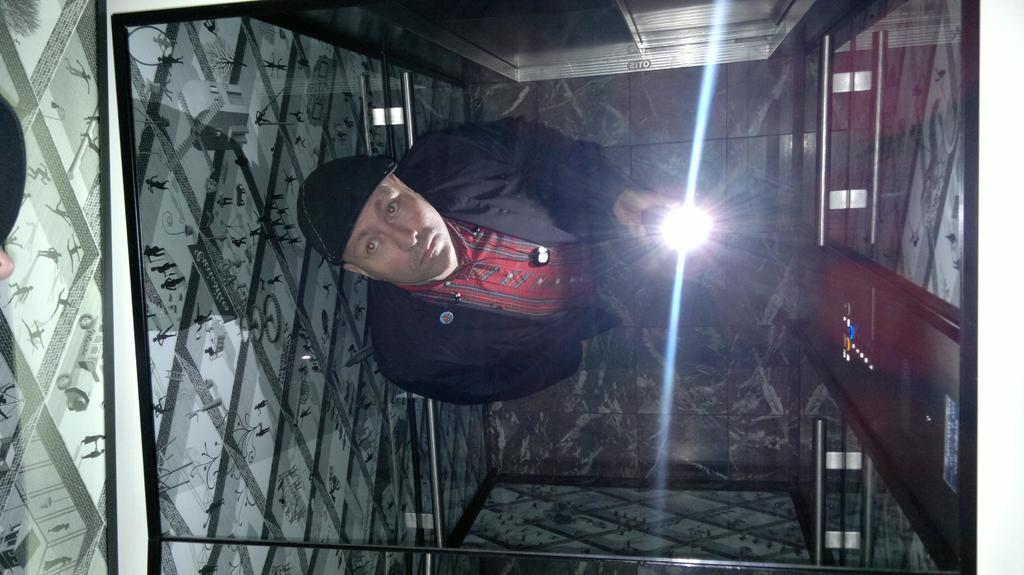Who is present in the image? There is a man present in the image. What is the man wearing? The man is wearing clothes and a cap. What is the man holding in his hand? The man is holding a torch in his hand. What color is the hen that the man is holding in the image? There is no hen present in the image; the man is holding a torch. What mark does the man make on the wall using a crayon in the image? There is no crayon or mark-making activity depicted in the image; the man is holding a torch. 